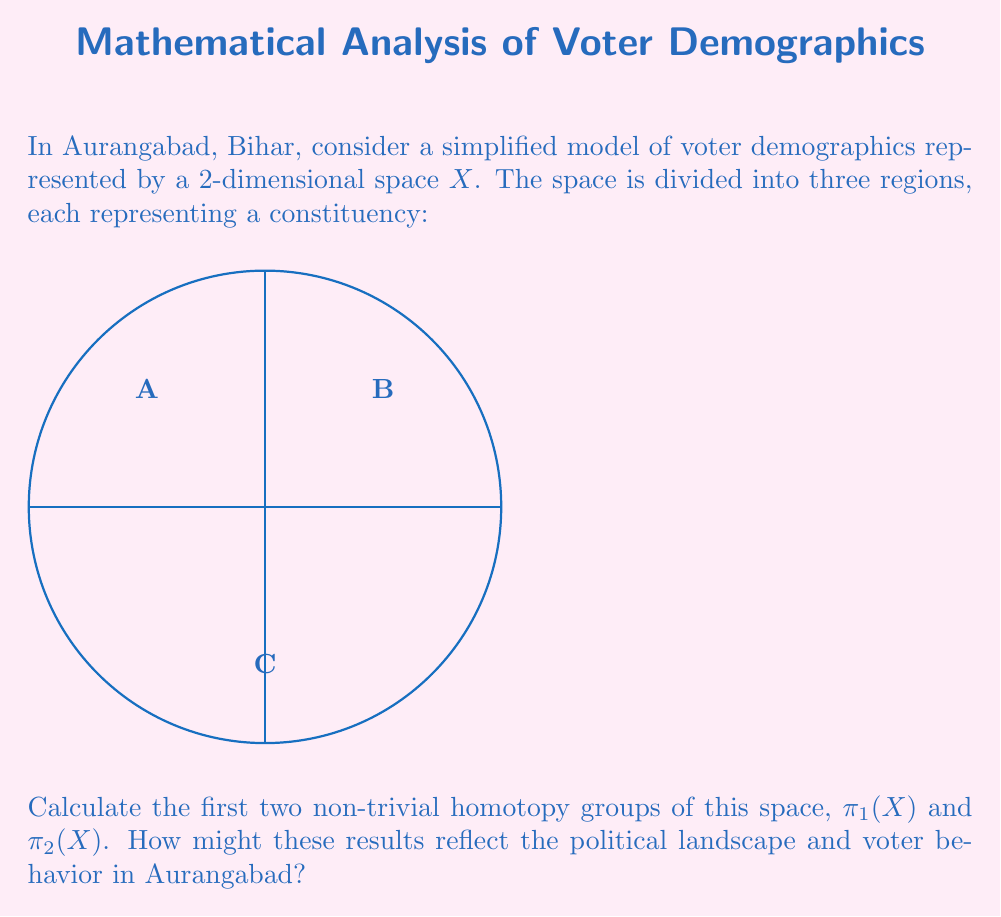Give your solution to this math problem. Let's approach this step-by-step:

1) First, we need to understand what the space $X$ represents. It's a 2-dimensional disk divided into three regions (A, B, and C), each representing a constituency in Aurangabad.

2) To calculate the homotopy groups, we need to analyze the topological properties of this space:
   - The space is path-connected (any two points can be connected by a continuous path).
   - It's simply connected (any loop can be continuously shrunk to a point).
   - It's contractible (it can be continuously deformed to a point).

3) For the first homotopy group $\pi_1(X)$:
   - Since the space is simply connected, all loops are homotopic to a point.
   - Therefore, $\pi_1(X) \cong 0$ (the trivial group).

4) For the second homotopy group $\pi_2(X)$:
   - The space is contractible, which means all spheres mapped into it can be continuously deformed to a point.
   - Thus, $\pi_2(X) \cong 0$ as well.

5) Interpretation in the context of Aurangabad's political landscape:
   - $\pi_1(X) \cong 0$ suggests that voters can freely move between constituencies without encountering "obstacles", indicating potential for voter migration or shifting allegiances.
   - $\pi_2(X) \cong 0$ implies that there are no "voids" or significant separations in the voter demographic space, suggesting a relatively homogeneous political landscape.

These results indicate a politically interconnected region where voter behaviors and demographics are smoothly distributed across constituencies, reflecting the unified cultural and political identity of Aurangabad, Bihar.
Answer: $\pi_1(X) \cong 0$, $\pi_2(X) \cong 0$ 